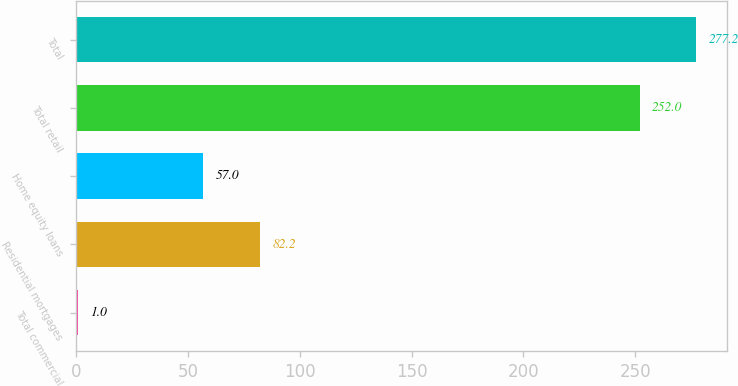<chart> <loc_0><loc_0><loc_500><loc_500><bar_chart><fcel>Total commercial<fcel>Residential mortgages<fcel>Home equity loans<fcel>Total retail<fcel>Total<nl><fcel>1<fcel>82.2<fcel>57<fcel>252<fcel>277.2<nl></chart> 